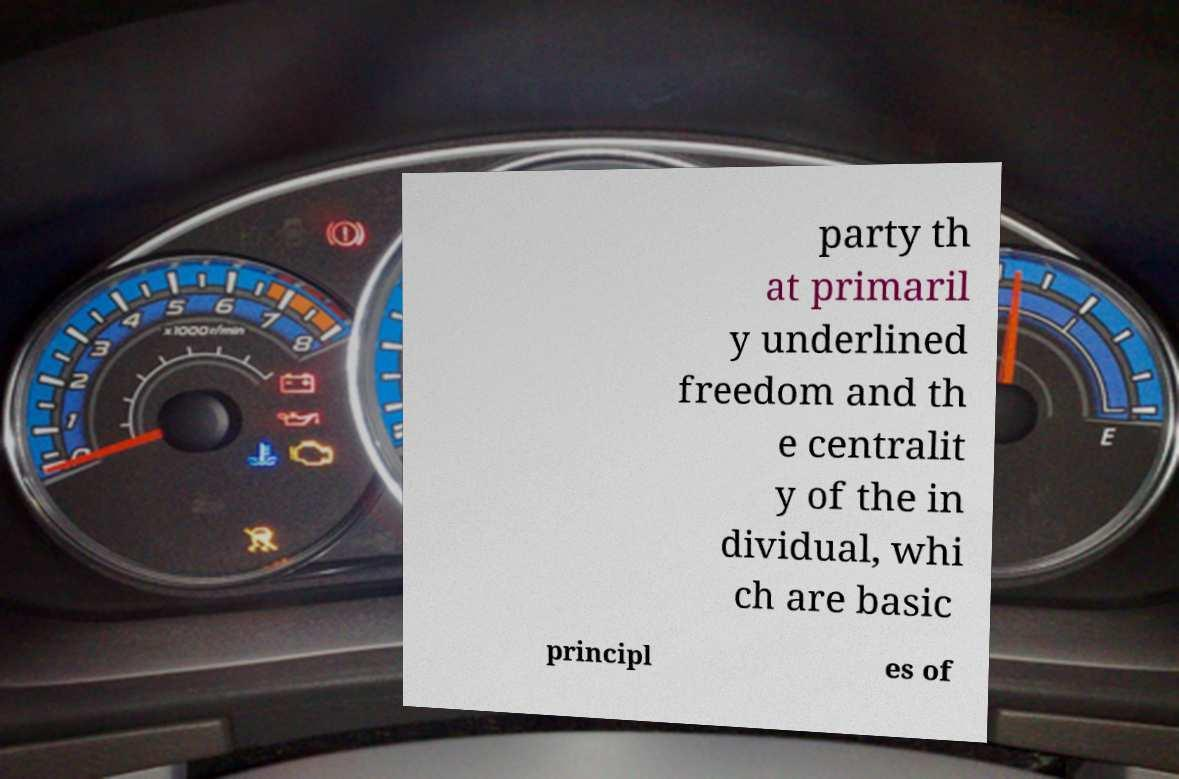I need the written content from this picture converted into text. Can you do that? party th at primaril y underlined freedom and th e centralit y of the in dividual, whi ch are basic principl es of 